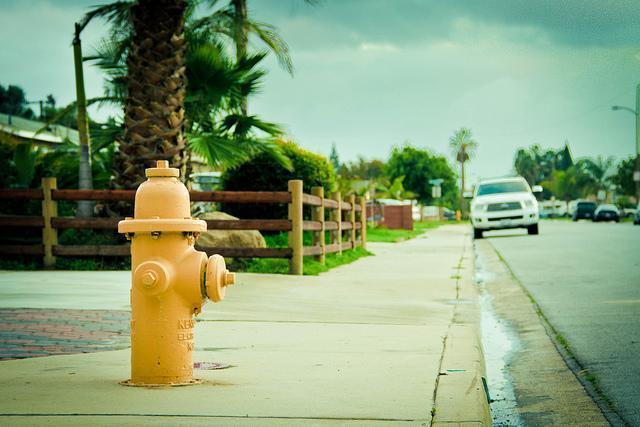How many poles in the fence?
Give a very brief answer. 6. How many people are holding bananas?
Give a very brief answer. 0. 